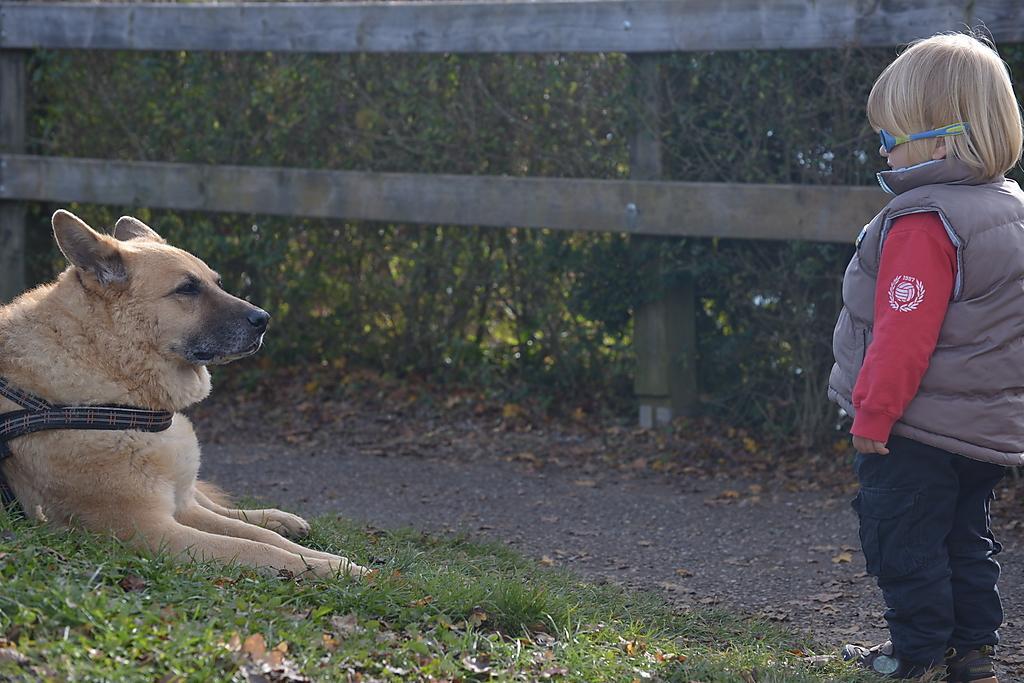Could you give a brief overview of what you see in this image? In this image I can see on the left side a dog is sitting on the grass, on the right side a girl is standing and looking at this dog. She is wearing a coat and a trouser, in the middle it looks like a wooden fence, there are plants in it. 